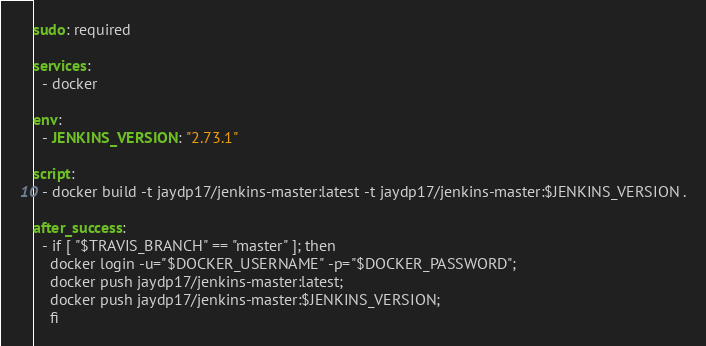Convert code to text. <code><loc_0><loc_0><loc_500><loc_500><_YAML_>sudo: required

services:
  - docker

env:
  - JENKINS_VERSION: "2.73.1"

script:
  - docker build -t jaydp17/jenkins-master:latest -t jaydp17/jenkins-master:$JENKINS_VERSION .

after_success:
  - if [ "$TRAVIS_BRANCH" == "master" ]; then
    docker login -u="$DOCKER_USERNAME" -p="$DOCKER_PASSWORD";
    docker push jaydp17/jenkins-master:latest;
    docker push jaydp17/jenkins-master:$JENKINS_VERSION;
    fi
</code> 